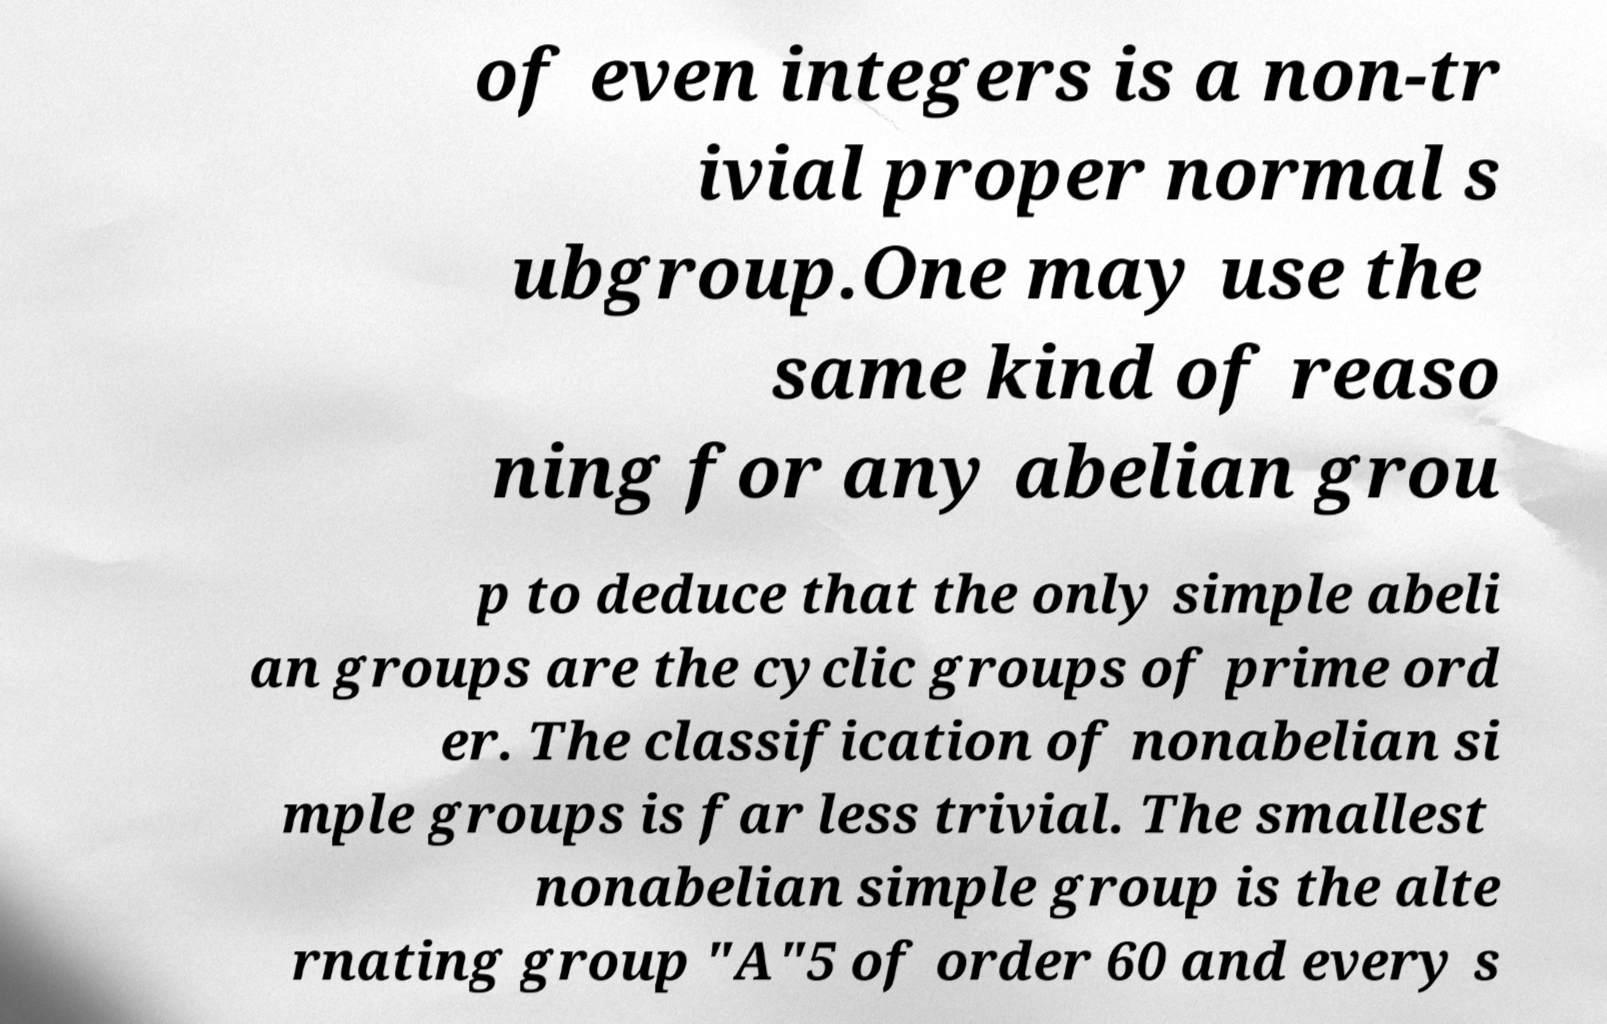What messages or text are displayed in this image? I need them in a readable, typed format. of even integers is a non-tr ivial proper normal s ubgroup.One may use the same kind of reaso ning for any abelian grou p to deduce that the only simple abeli an groups are the cyclic groups of prime ord er. The classification of nonabelian si mple groups is far less trivial. The smallest nonabelian simple group is the alte rnating group "A"5 of order 60 and every s 